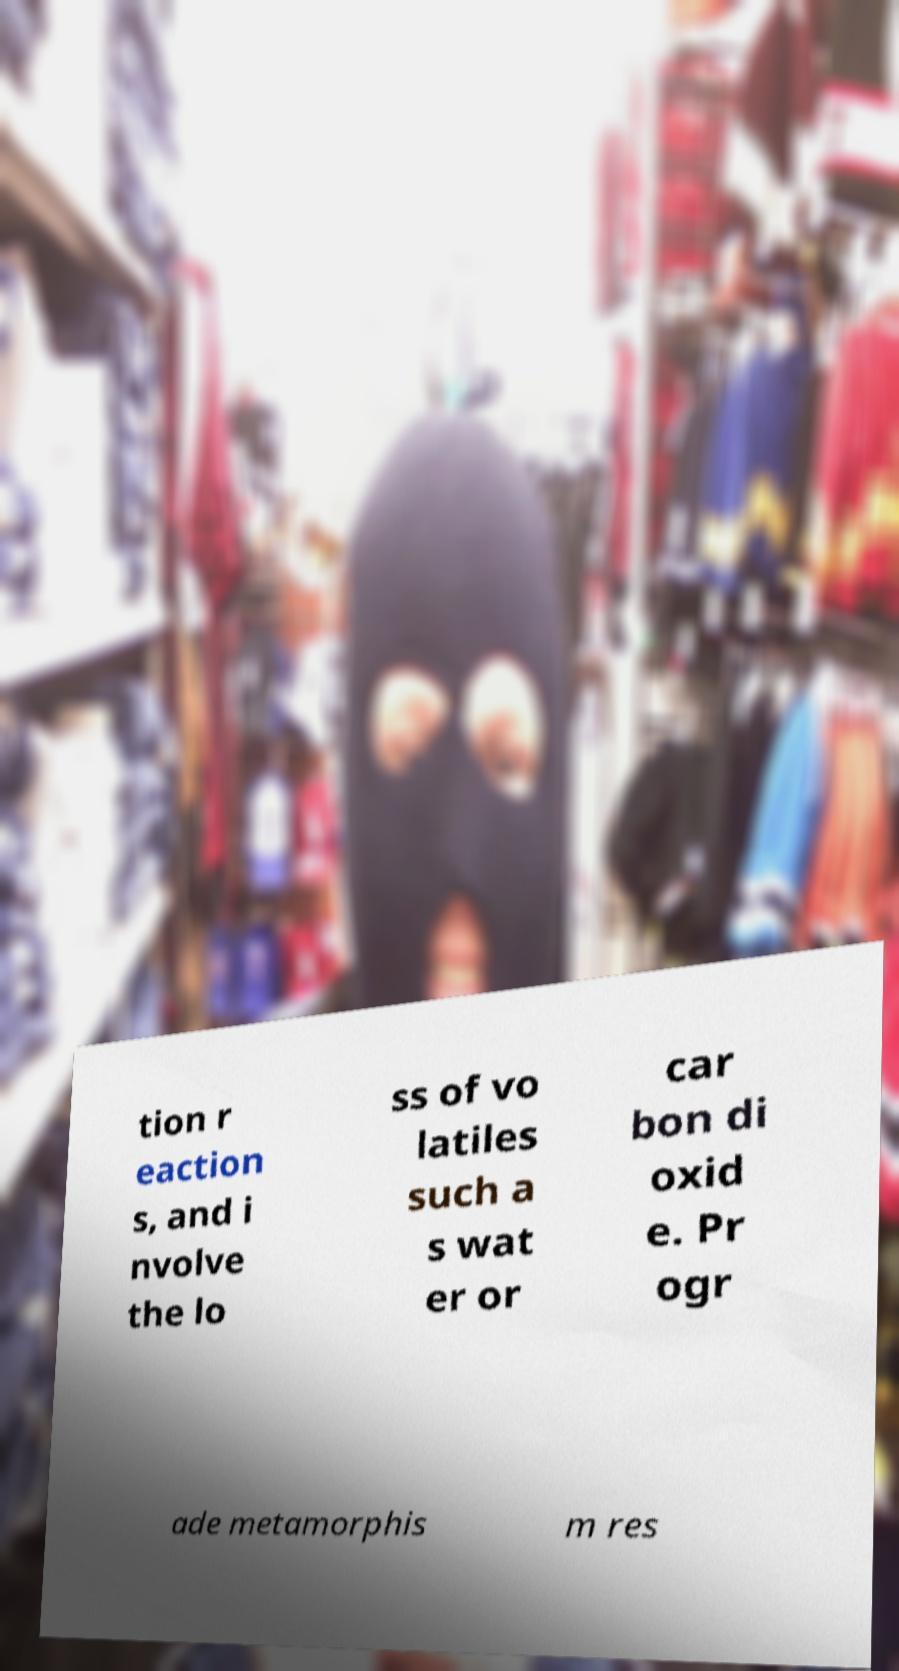What messages or text are displayed in this image? I need them in a readable, typed format. tion r eaction s, and i nvolve the lo ss of vo latiles such a s wat er or car bon di oxid e. Pr ogr ade metamorphis m res 